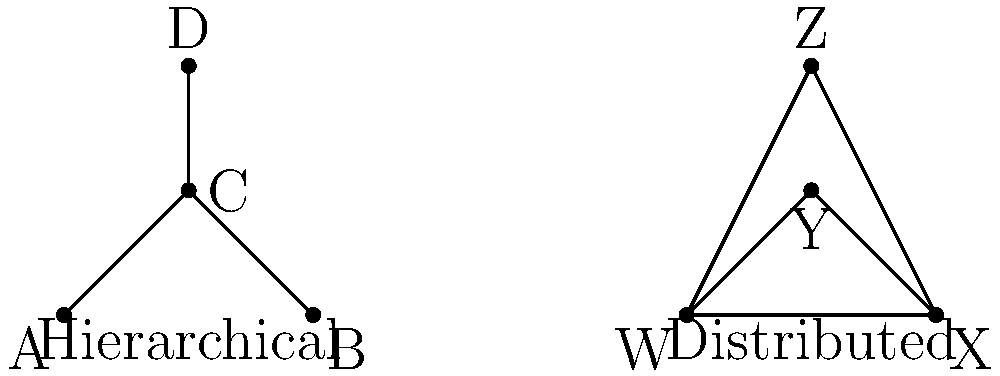Compare the hierarchical and distributed network structures shown in the diagram. Which structure would be more conducive to fostering ethical decision-making that prioritizes human judgment and empathy in an organization? Explain your reasoning. To answer this question, we need to consider the characteristics of both network structures and how they relate to ethical decision-making that prioritizes human judgment and empathy:

1. Hierarchical structure:
   - Clear chain of command (D → C → A/B)
   - Top-down decision-making process
   - Limited lateral communication

2. Distributed structure:
   - All nodes (W, X, Y, Z) are interconnected
   - No clear superiority or subordination
   - Open communication channels between all members

3. Ethical decision-making considerations:
   a) Human judgment: Requires diverse perspectives and input from various stakeholders
   b) Empathy: Necessitates understanding multiple viewpoints and experiences

4. Analysis:
   - The hierarchical structure may limit the flow of information and perspectives, potentially constraining human judgment and empathy.
   - The distributed structure allows for more open communication and equal participation, which can foster a broader range of human judgments and empathetic understanding.

5. Conclusion:
   The distributed network structure is more conducive to fostering ethical decision-making that prioritizes human judgment and empathy because it:
   - Encourages open dialogue and diverse perspectives
   - Allows for equal participation in decision-making processes
   - Facilitates the sharing of experiences and viewpoints, enhancing empathy

This structure aligns better with the ethical approach that values human judgment and empathy over computational models, as it emphasizes human interaction and collective wisdom.
Answer: Distributed structure 